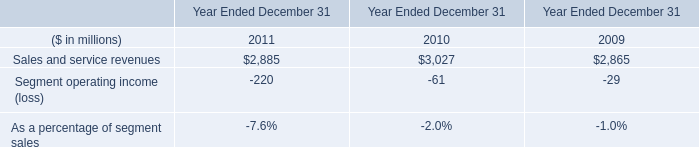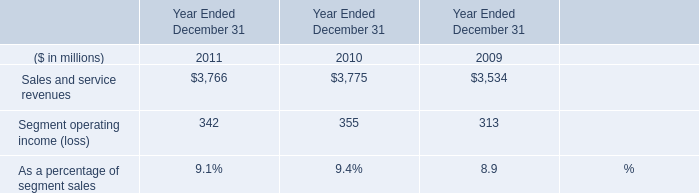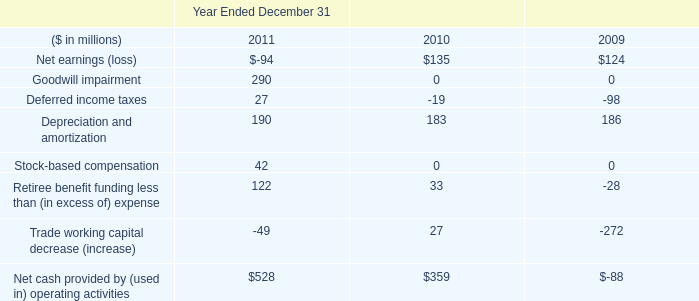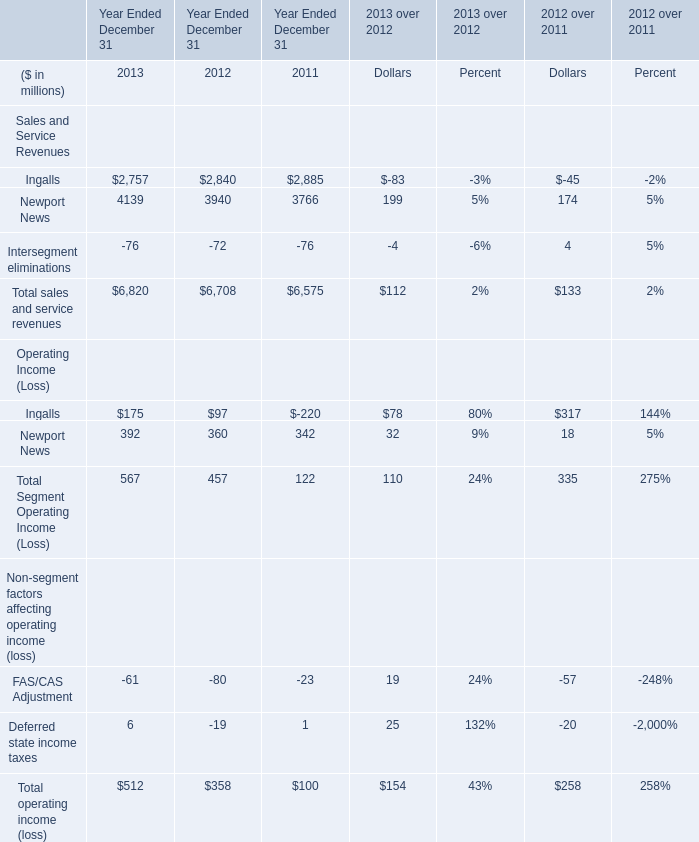What's the average of the Sales and service revenues in the years where Sales and service revenues is greater than 0? (in million) 
Computations: (((2885 + 3027) + 2865) / 3)
Answer: 2925.66667. 